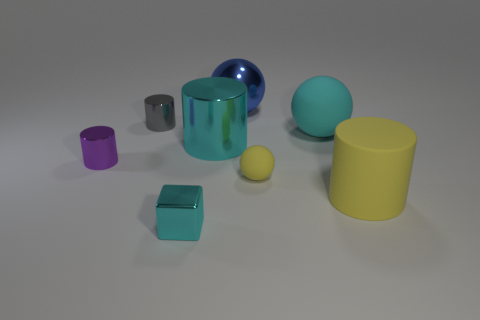What is the color of the tiny thing to the right of the object that is in front of the thing that is right of the cyan matte object?
Ensure brevity in your answer.  Yellow. Does the tiny metallic thing that is behind the cyan cylinder have the same shape as the small yellow matte object?
Offer a terse response. No. What number of cyan metallic balls are there?
Give a very brief answer. 0. What number of purple metallic cylinders are the same size as the yellow matte ball?
Provide a succinct answer. 1. What is the big blue sphere made of?
Your answer should be compact. Metal. Do the big rubber ball and the shiny cylinder that is left of the small gray metallic cylinder have the same color?
Give a very brief answer. No. Is there anything else that has the same size as the gray cylinder?
Provide a succinct answer. Yes. There is a cylinder that is on the left side of the small cyan metallic block and on the right side of the purple object; what is its size?
Provide a short and direct response. Small. What is the shape of the large cyan object that is the same material as the tiny gray cylinder?
Provide a short and direct response. Cylinder. Do the purple cylinder and the large cyan thing that is on the right side of the cyan metallic cylinder have the same material?
Make the answer very short. No. 